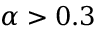<formula> <loc_0><loc_0><loc_500><loc_500>{ \alpha } > 0 . 3</formula> 